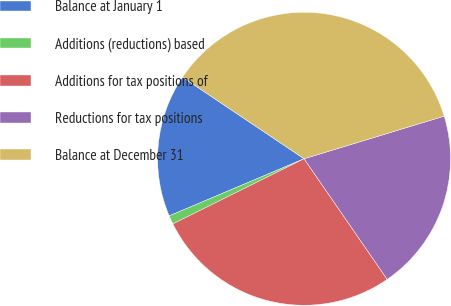<chart> <loc_0><loc_0><loc_500><loc_500><pie_chart><fcel>Balance at January 1<fcel>Additions (reductions) based<fcel>Additions for tax positions of<fcel>Reductions for tax positions<fcel>Balance at December 31<nl><fcel>15.79%<fcel>0.96%<fcel>27.27%<fcel>20.1%<fcel>35.89%<nl></chart> 